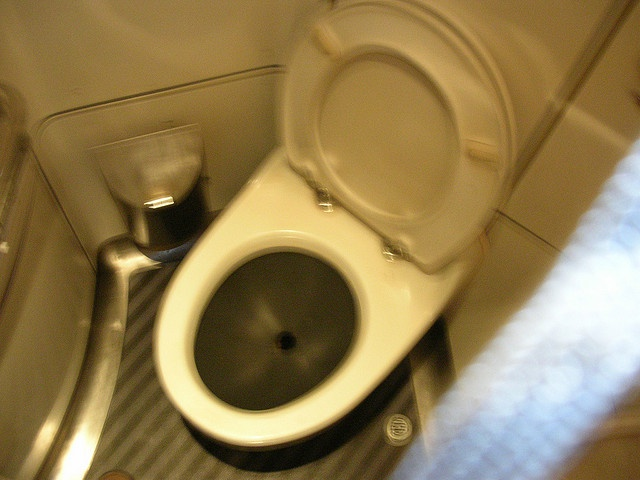Describe the objects in this image and their specific colors. I can see a toilet in olive, tan, khaki, and black tones in this image. 